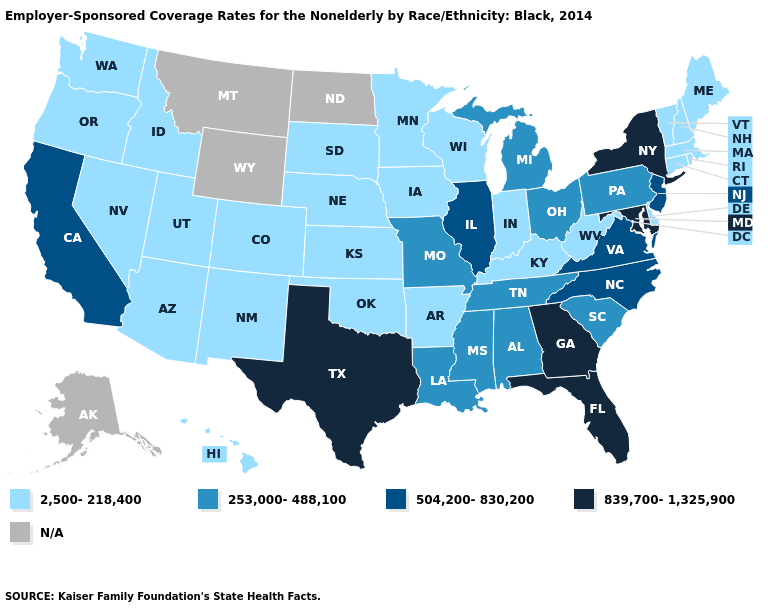Does Missouri have the lowest value in the USA?
Write a very short answer. No. Does California have the lowest value in the West?
Write a very short answer. No. What is the highest value in states that border California?
Write a very short answer. 2,500-218,400. Does Arizona have the highest value in the West?
Short answer required. No. What is the highest value in states that border Vermont?
Be succinct. 839,700-1,325,900. What is the highest value in the USA?
Be succinct. 839,700-1,325,900. Which states hav the highest value in the MidWest?
Write a very short answer. Illinois. Name the states that have a value in the range 839,700-1,325,900?
Keep it brief. Florida, Georgia, Maryland, New York, Texas. Among the states that border Texas , does Louisiana have the highest value?
Keep it brief. Yes. How many symbols are there in the legend?
Concise answer only. 5. Does Ohio have the highest value in the MidWest?
Answer briefly. No. What is the highest value in states that border Idaho?
Keep it brief. 2,500-218,400. Does New Jersey have the lowest value in the Northeast?
Give a very brief answer. No. 